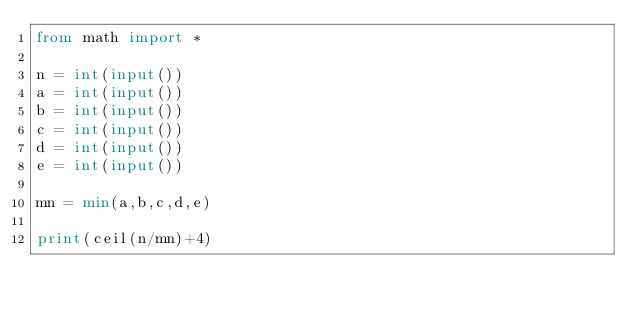Convert code to text. <code><loc_0><loc_0><loc_500><loc_500><_Python_>from math import *

n = int(input())
a = int(input())
b = int(input())
c = int(input())
d = int(input())
e = int(input())

mn = min(a,b,c,d,e)

print(ceil(n/mn)+4)</code> 